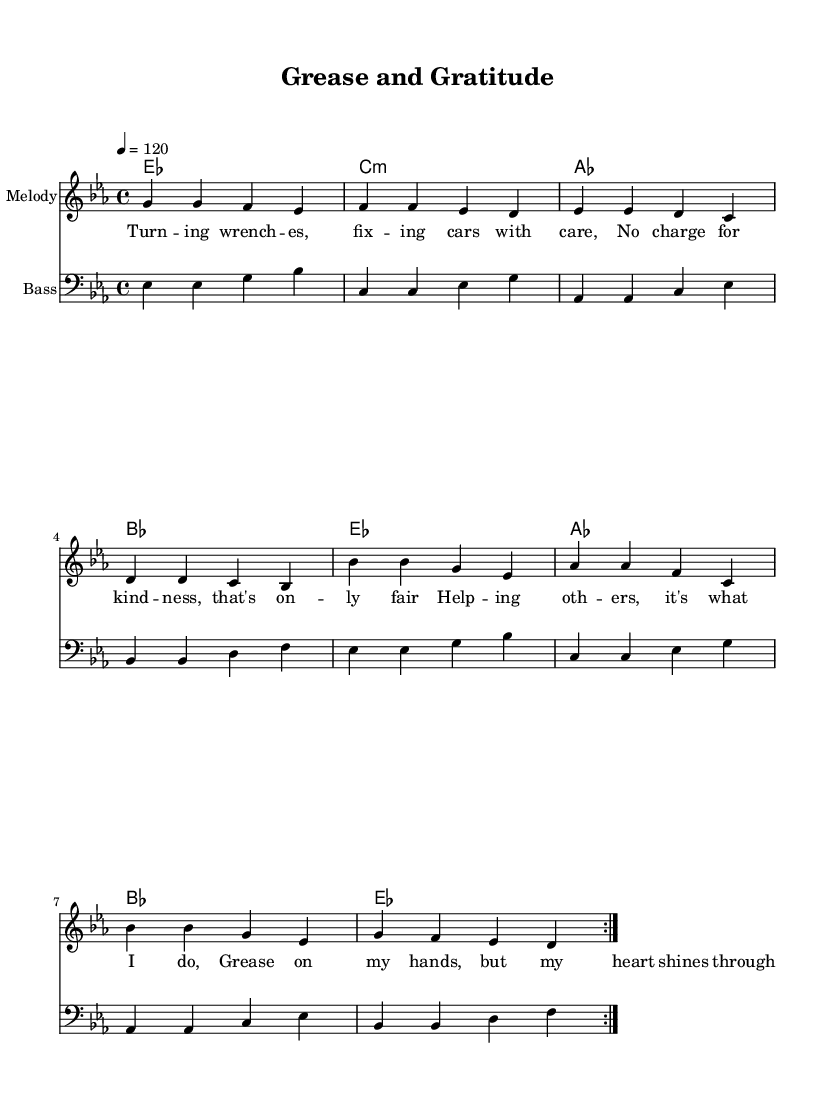What is the key signature of this music? The key signature indicates the presence of three flats, which represents E flat major or C minor. Since the piece is primarily centered around E flat chords, it is most accurately described as E flat major.
Answer: E flat major What is the time signature of this music? The time signature shown at the beginning of the score is 4/4, meaning there are four beats in a measure and the quarter note receives one beat.
Answer: 4/4 What is the tempo marking for this piece? The tempo marking indicates a speed of 120 beats per minute, which is represented by "4 = 120" in the score, meaning that the metronome should tick at this speed.
Answer: 120 How many measures are repeated in the melody? The melody section is marked to repeat with "volta 2", indicating that there are two sets of the same measures presented before moving on.
Answer: 2 What kind of musical genre does this piece belong to? The overall sound structure, rhythmic patterns, and lifestyle-themed lyrics align with the qualities found in Funk music, characterized by its strong bass lines and upbeat tempo.
Answer: Funk What is the main theme of the lyrics? The lyrics reflect community service, emphasizing caring actions like helping others and providing free car repairs, which aligns with the goodwill sentiment conveyed in the title "Grease and Gratitude."
Answer: Helping others 